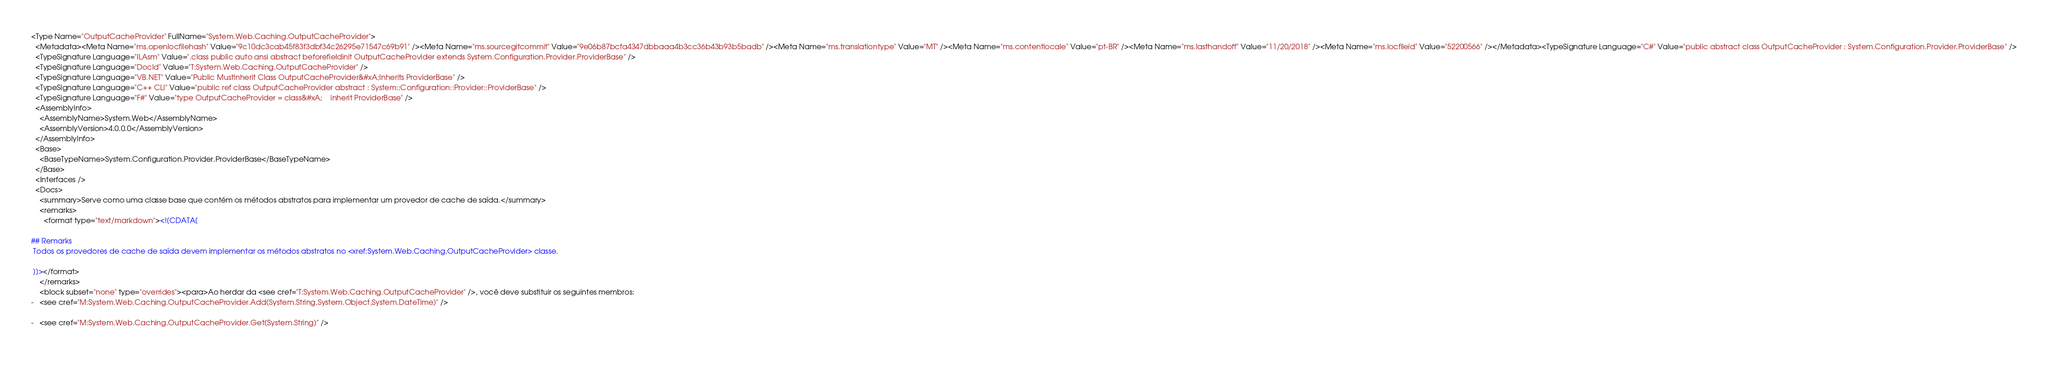Convert code to text. <code><loc_0><loc_0><loc_500><loc_500><_XML_><Type Name="OutputCacheProvider" FullName="System.Web.Caching.OutputCacheProvider">
  <Metadata><Meta Name="ms.openlocfilehash" Value="9c10dc3cab45f83f3dbf34c26295e71547c69b91" /><Meta Name="ms.sourcegitcommit" Value="9e06b87bcfa4347dbbaaa4b3cc36b43b93b5badb" /><Meta Name="ms.translationtype" Value="MT" /><Meta Name="ms.contentlocale" Value="pt-BR" /><Meta Name="ms.lasthandoff" Value="11/20/2018" /><Meta Name="ms.locfileid" Value="52200566" /></Metadata><TypeSignature Language="C#" Value="public abstract class OutputCacheProvider : System.Configuration.Provider.ProviderBase" />
  <TypeSignature Language="ILAsm" Value=".class public auto ansi abstract beforefieldinit OutputCacheProvider extends System.Configuration.Provider.ProviderBase" />
  <TypeSignature Language="DocId" Value="T:System.Web.Caching.OutputCacheProvider" />
  <TypeSignature Language="VB.NET" Value="Public MustInherit Class OutputCacheProvider&#xA;Inherits ProviderBase" />
  <TypeSignature Language="C++ CLI" Value="public ref class OutputCacheProvider abstract : System::Configuration::Provider::ProviderBase" />
  <TypeSignature Language="F#" Value="type OutputCacheProvider = class&#xA;    inherit ProviderBase" />
  <AssemblyInfo>
    <AssemblyName>System.Web</AssemblyName>
    <AssemblyVersion>4.0.0.0</AssemblyVersion>
  </AssemblyInfo>
  <Base>
    <BaseTypeName>System.Configuration.Provider.ProviderBase</BaseTypeName>
  </Base>
  <Interfaces />
  <Docs>
    <summary>Serve como uma classe base que contém os métodos abstratos para implementar um provedor de cache de saída.</summary>
    <remarks>
      <format type="text/markdown"><![CDATA[  
  
## Remarks  
 Todos os provedores de cache de saída devem implementar os métodos abstratos no <xref:System.Web.Caching.OutputCacheProvider> classe.  
  
 ]]></format>
    </remarks>
    <block subset="none" type="overrides"><para>Ao herdar da <see cref="T:System.Web.Caching.OutputCacheProvider" />, você deve substituir os seguintes membros: 
-   <see cref="M:System.Web.Caching.OutputCacheProvider.Add(System.String,System.Object,System.DateTime)" />  
  
-   <see cref="M:System.Web.Caching.OutputCacheProvider.Get(System.String)" />  
  </code> 